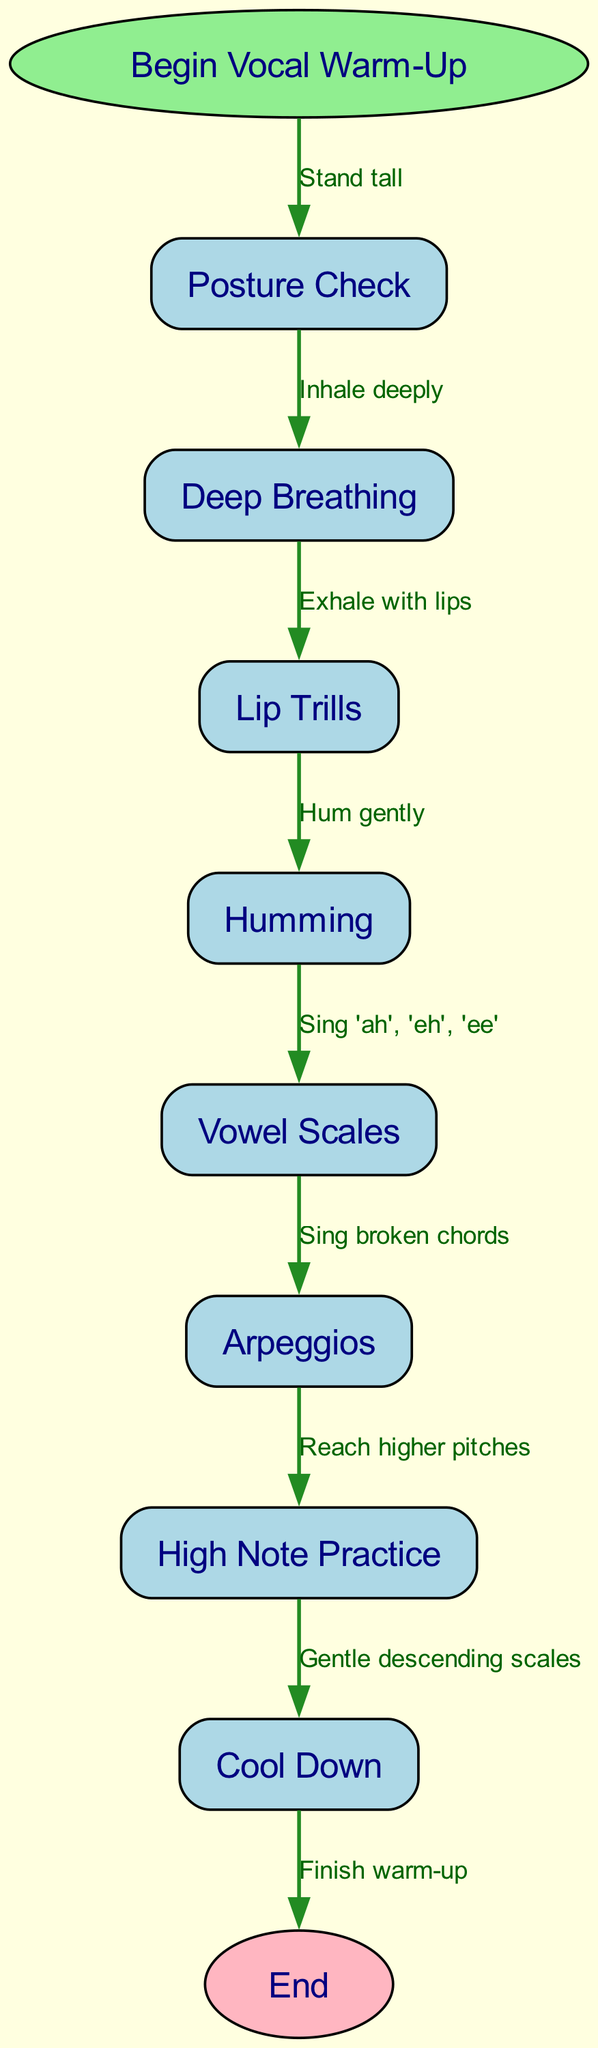What is the first step in the vocal warm-up? The diagram starts with the node labeled "Begin Vocal Warm-Up," which leads to the next node "Posture Check." Thus, the first step after the start is "Posture Check."
Answer: Posture Check How many nodes are present in the flow chart? The flow chart contains a total of 8 nodes: 1 start node, 1 end node, and 6 additional nodes for the warm-up steps. Therefore, the total is 8 nodes.
Answer: 8 What do you do after "Humming"? The edge labeled "Hum gently" connects "Humming" to "Vowel Scales," indicating that after humming, the next step is to proceed to vowel scales.
Answer: Vowel Scales What is the relationship between "High Note Practice" and "Cool Down"? The edge labeled "Gentle descending scales" connects "High Note Practice" to "Cool Down." This means that "High Note Practice" directly precedes "Cool Down" in the sequence of steps.
Answer: Cool Down What step involves reaching higher pitches? The node labeled "High Note Practice" specifically identifies the step focused on reaching higher pitches.
Answer: High Note Practice How many edges are connecting the nodes? The diagram indicates that there are 8 edges connecting the different nodes, representing the flow between each step in the vocal warm-up process.
Answer: 8 Which step comes after "Vowel Scales"? According to the connection labeled "Sing broken chords," the step that follows "Vowel Scales" is "Arpeggios."
Answer: Arpeggios At which point do you finish the warm-up? The end node labeled "End" signifies that the warm-up is finished after completing the step "Cool Down."
Answer: End What is the purpose of the "Lip Trills" step? The edge labeled "Exhale with lips" connects "Deep Breathing" to "Lip Trills," indicating that the purpose of this step is to exhale with the lips as part of the warm-up.
Answer: Exhale with lips 